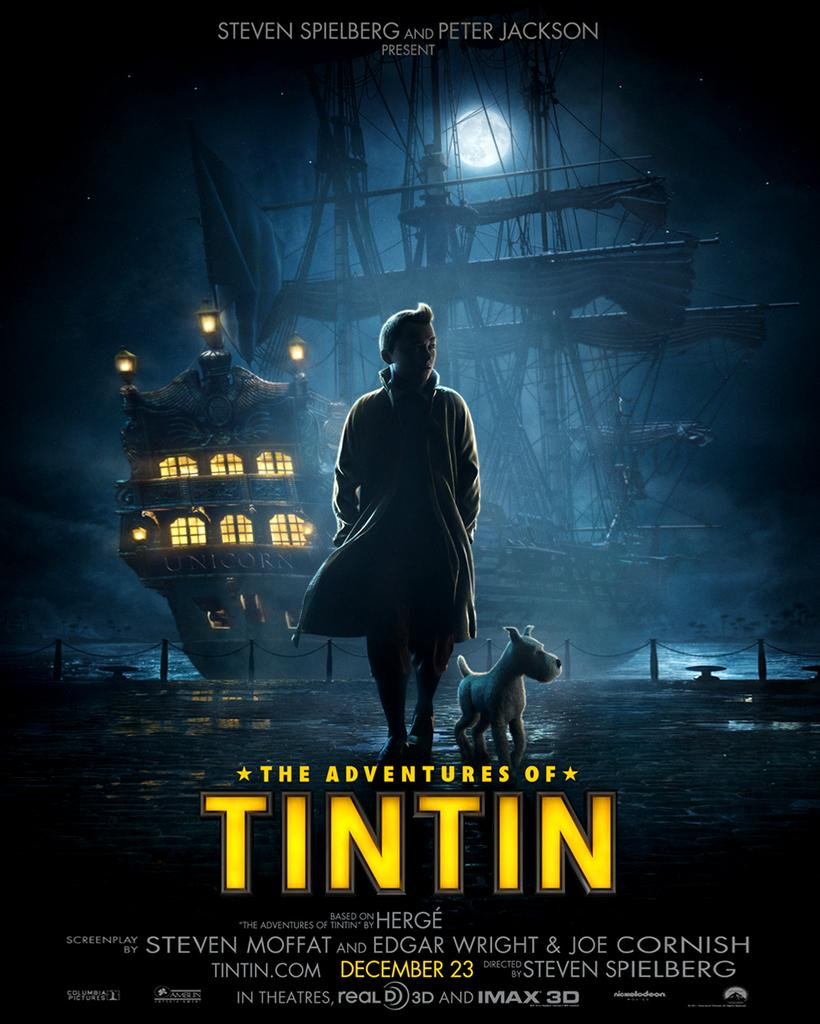<image>
Describe the image concisely. a movie poster for 'the adventures of tintin' 